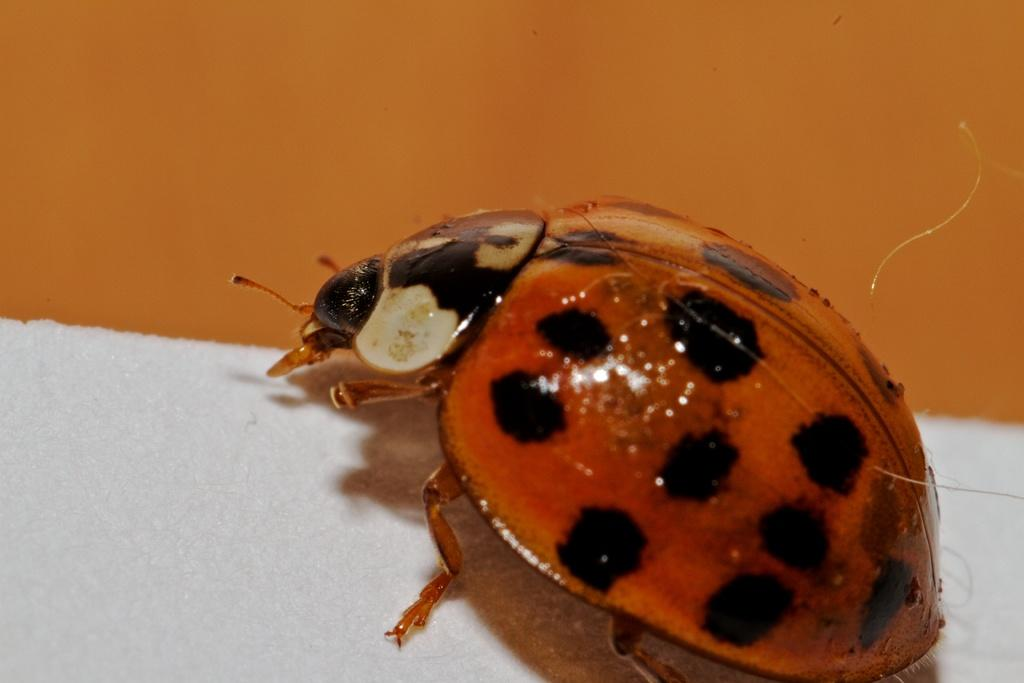What type of creature is present in the image? There is a bug in the image. What is located at the bottom of the image? There is a mat at the bottom of the image. What can be seen in the background of the image? There is a wall visible in the background of the image. What type of song is the bug singing in the image? There is no indication that the bug is singing a song in the image. 